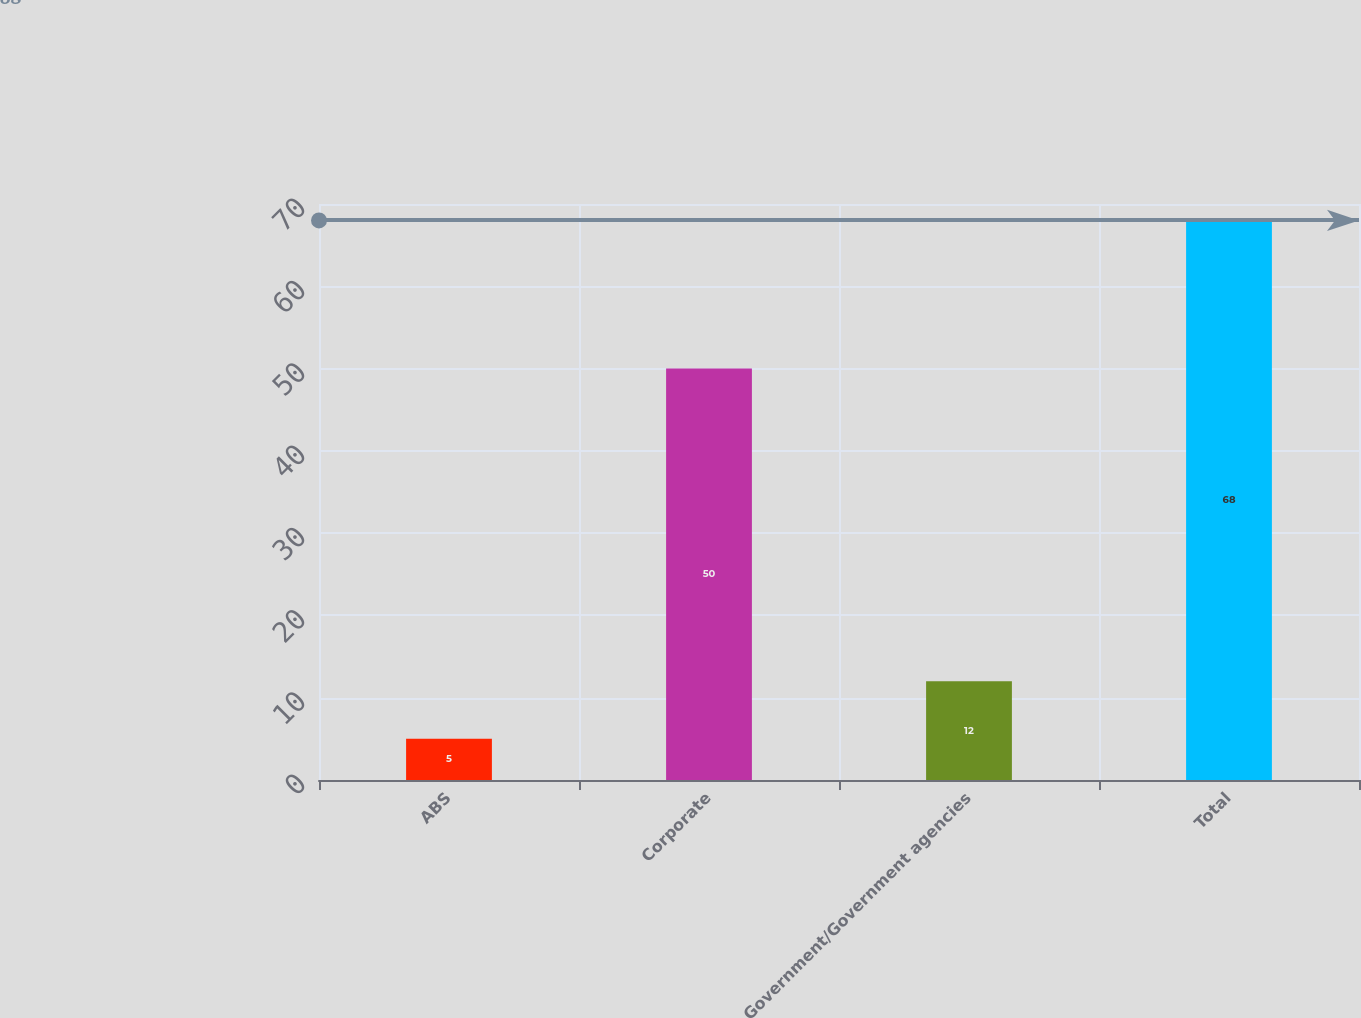Convert chart to OTSL. <chart><loc_0><loc_0><loc_500><loc_500><bar_chart><fcel>ABS<fcel>Corporate<fcel>Government/Government agencies<fcel>Total<nl><fcel>5<fcel>50<fcel>12<fcel>68<nl></chart> 